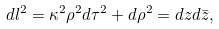Convert formula to latex. <formula><loc_0><loc_0><loc_500><loc_500>d l ^ { 2 } = \kappa ^ { 2 } \rho ^ { 2 } d \tau ^ { 2 } + d \rho ^ { 2 } = d z d \bar { z } ,</formula> 